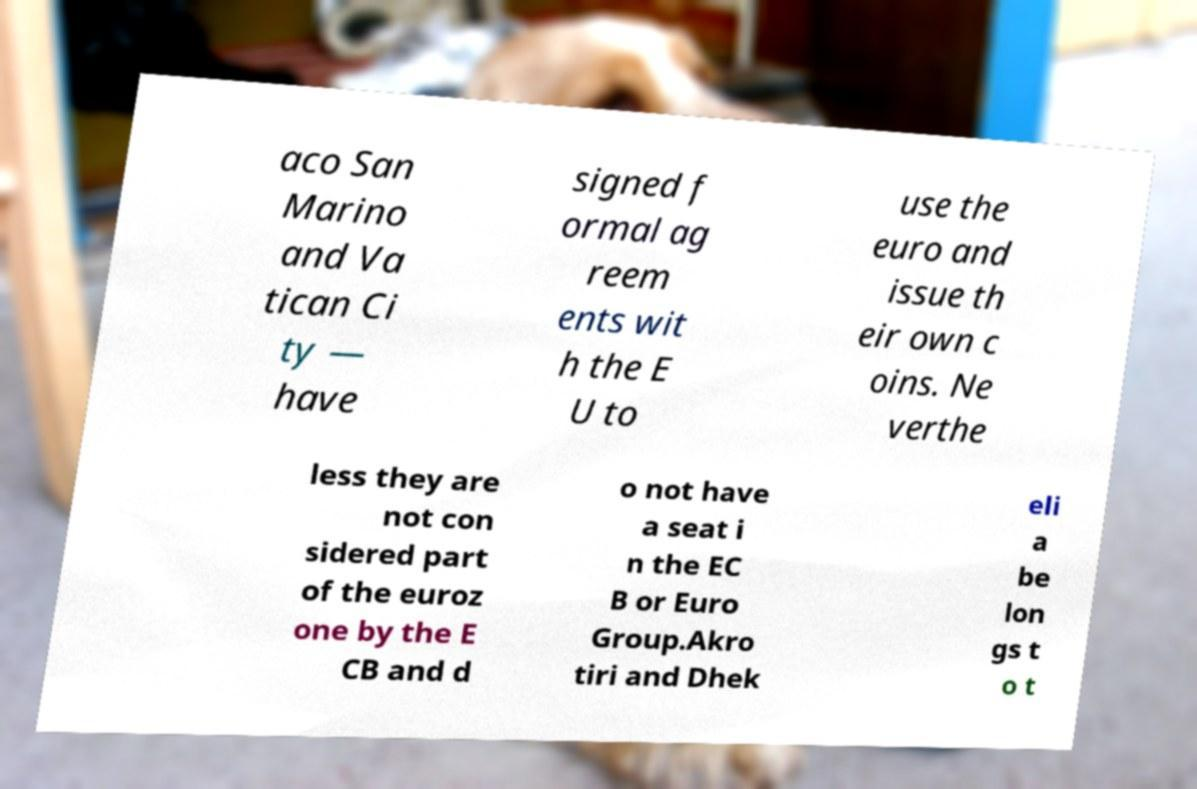Can you accurately transcribe the text from the provided image for me? aco San Marino and Va tican Ci ty — have signed f ormal ag reem ents wit h the E U to use the euro and issue th eir own c oins. Ne verthe less they are not con sidered part of the euroz one by the E CB and d o not have a seat i n the EC B or Euro Group.Akro tiri and Dhek eli a be lon gs t o t 